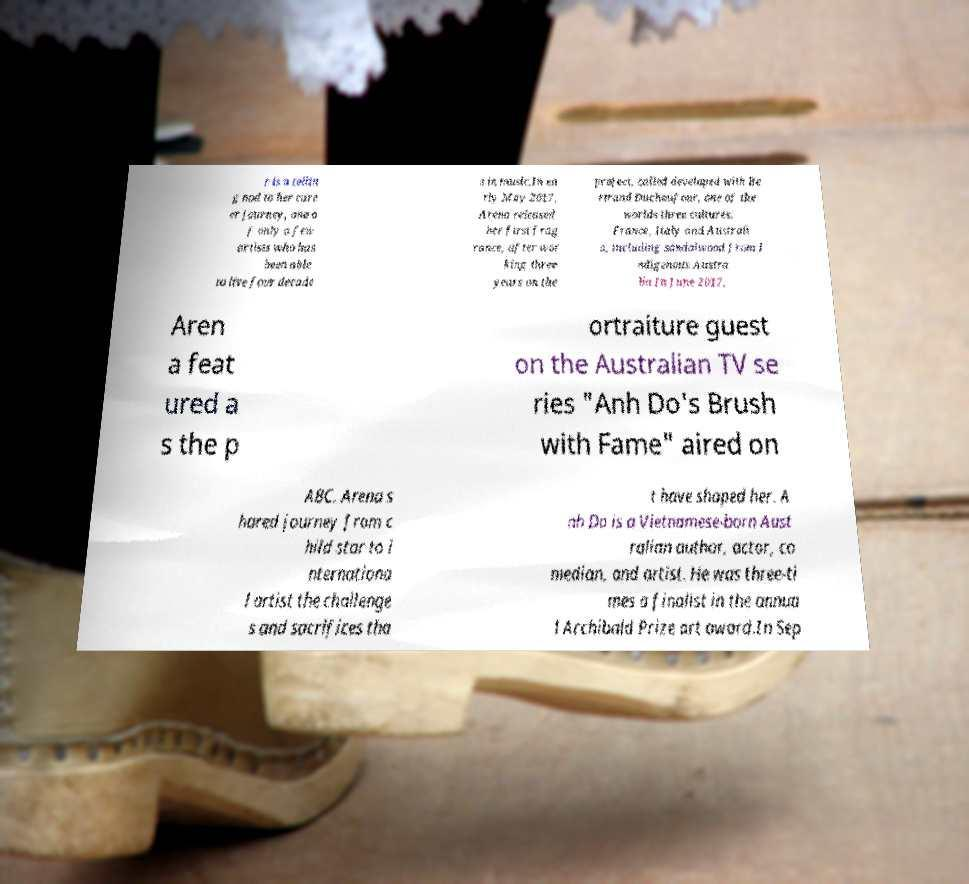For documentation purposes, I need the text within this image transcribed. Could you provide that? r is a tellin g nod to her care er journey, one o f only a few artists who has been able to live four decade s in music.In ea rly May 2017, Arena released her first frag rance, after wor king three years on the project, called developed with Be rtrand Duchaufour, one of the worlds three cultures: France, Italy and Australi a, including sandalwood from I ndigenous Austra lia.In June 2017, Aren a feat ured a s the p ortraiture guest on the Australian TV se ries "Anh Do's Brush with Fame" aired on ABC. Arena s hared journey from c hild star to i nternationa l artist the challenge s and sacrifices tha t have shaped her. A nh Do is a Vietnamese-born Aust ralian author, actor, co median, and artist. He was three-ti mes a finalist in the annua l Archibald Prize art award.In Sep 